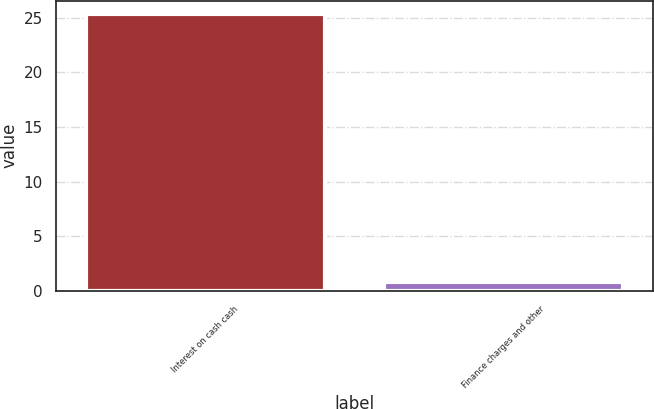<chart> <loc_0><loc_0><loc_500><loc_500><bar_chart><fcel>Interest on cash cash<fcel>Finance charges and other<nl><fcel>25.3<fcel>0.8<nl></chart> 